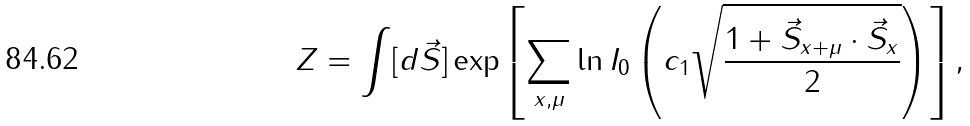<formula> <loc_0><loc_0><loc_500><loc_500>Z = \int [ d \vec { S } ] \exp \left [ \sum _ { x , \mu } \ln I _ { 0 } \left ( c _ { 1 } \sqrt { \frac { 1 + \vec { S } _ { x + \mu } \cdot \vec { S } _ { x } } { 2 } } \right ) \right ] ,</formula> 